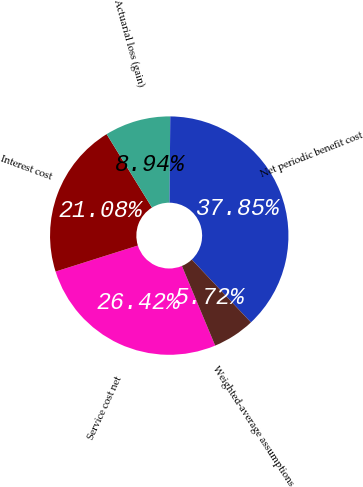Convert chart. <chart><loc_0><loc_0><loc_500><loc_500><pie_chart><fcel>Service cost net<fcel>Interest cost<fcel>Actuarial loss (gain)<fcel>Net periodic benefit cost<fcel>Weighted-average assumptions<nl><fcel>26.42%<fcel>21.08%<fcel>8.94%<fcel>37.85%<fcel>5.72%<nl></chart> 